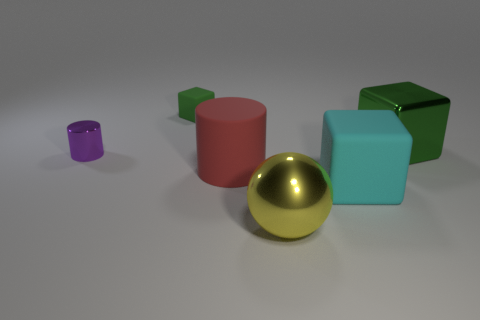Add 2 yellow things. How many objects exist? 8 Subtract all large cyan cubes. How many cubes are left? 2 Subtract all cyan cubes. How many cubes are left? 2 Subtract all cylinders. How many objects are left? 4 Subtract all gray cubes. How many blue spheres are left? 0 Subtract all big yellow shiny spheres. Subtract all cubes. How many objects are left? 2 Add 4 big green metallic things. How many big green metallic things are left? 5 Add 3 tiny green matte objects. How many tiny green matte objects exist? 4 Subtract 0 yellow cylinders. How many objects are left? 6 Subtract 1 cylinders. How many cylinders are left? 1 